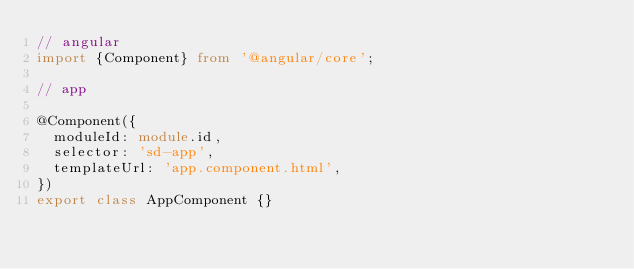<code> <loc_0><loc_0><loc_500><loc_500><_TypeScript_>// angular
import {Component} from '@angular/core';

// app

@Component({
  moduleId: module.id,
  selector: 'sd-app',
  templateUrl: 'app.component.html',
})
export class AppComponent {}
</code> 